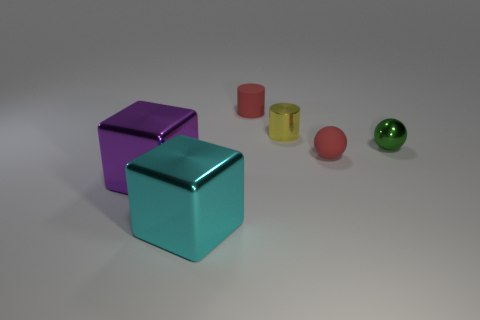What shape is the tiny metallic thing that is right of the tiny yellow object?
Your answer should be very brief. Sphere. How many metallic things are both left of the yellow thing and behind the big purple object?
Your answer should be compact. 0. What number of other things are the same size as the green metal thing?
Offer a very short reply. 3. There is a red object behind the small metallic cylinder; does it have the same shape as the tiny metal object that is left of the red rubber sphere?
Provide a short and direct response. Yes. What number of objects are tiny rubber balls or large cubes that are to the right of the large purple block?
Ensure brevity in your answer.  2. There is a object that is both left of the yellow shiny cylinder and behind the red rubber sphere; what is it made of?
Ensure brevity in your answer.  Rubber. There is a cube that is made of the same material as the cyan thing; what color is it?
Your response must be concise. Purple. How many things are small rubber things or small metal cylinders?
Give a very brief answer. 3. There is a red cylinder; does it have the same size as the metallic object that is right of the tiny matte sphere?
Give a very brief answer. Yes. What is the color of the cylinder that is in front of the small rubber thing on the left side of the shiny object that is behind the small metal sphere?
Provide a short and direct response. Yellow. 